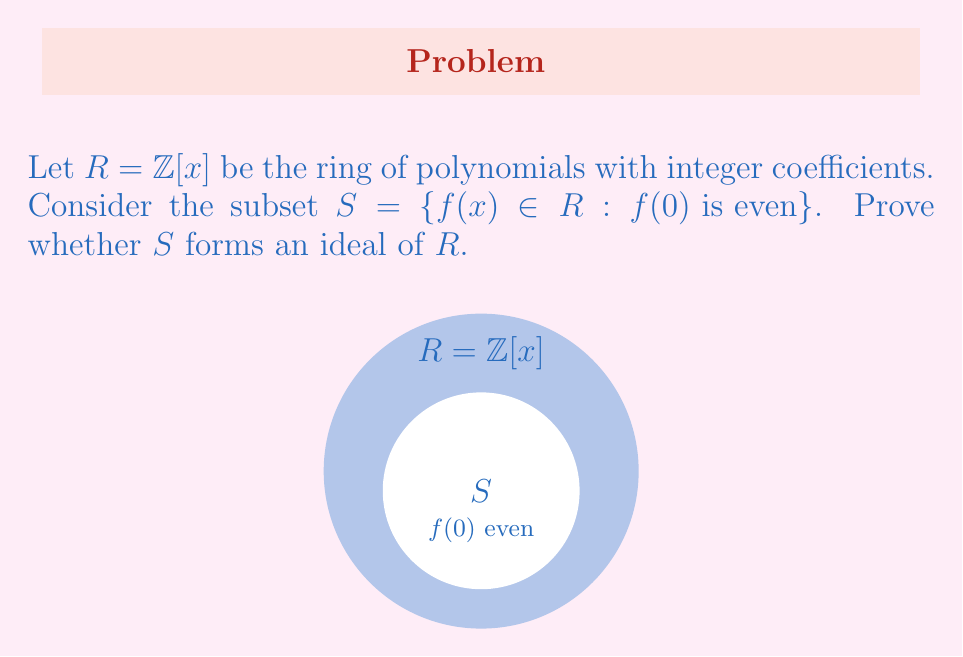Provide a solution to this math problem. To prove whether $S$ forms an ideal of $R$, we need to check three conditions:

1. Closure under addition:
Let $f(x), g(x) \in S$. Then $f(0)$ and $g(0)$ are even integers.
$(f+g)(0) = f(0) + g(0)$ is the sum of two even integers, which is even.
Therefore, $(f+g)(x) \in S$.

2. Closure under subtraction:
Let $f(x), g(x) \in S$. Then $f(0)$ and $g(0)$ are even integers.
$(f-g)(0) = f(0) - g(0)$ is the difference of two even integers, which is even.
Therefore, $(f-g)(x) \in S$.

3. Absorption under multiplication:
Let $f(x) \in S$ and $r(x) \in R$.
$(rf)(0) = r(0)f(0)$
Here, $f(0)$ is even, but $r(0)$ can be any integer.
The product of an even number and any integer is always even.
Therefore, $(rf)(x) \in S$.

Since all three conditions are satisfied, $S$ forms an ideal of $R$.
Answer: $S$ is an ideal of $R$. 